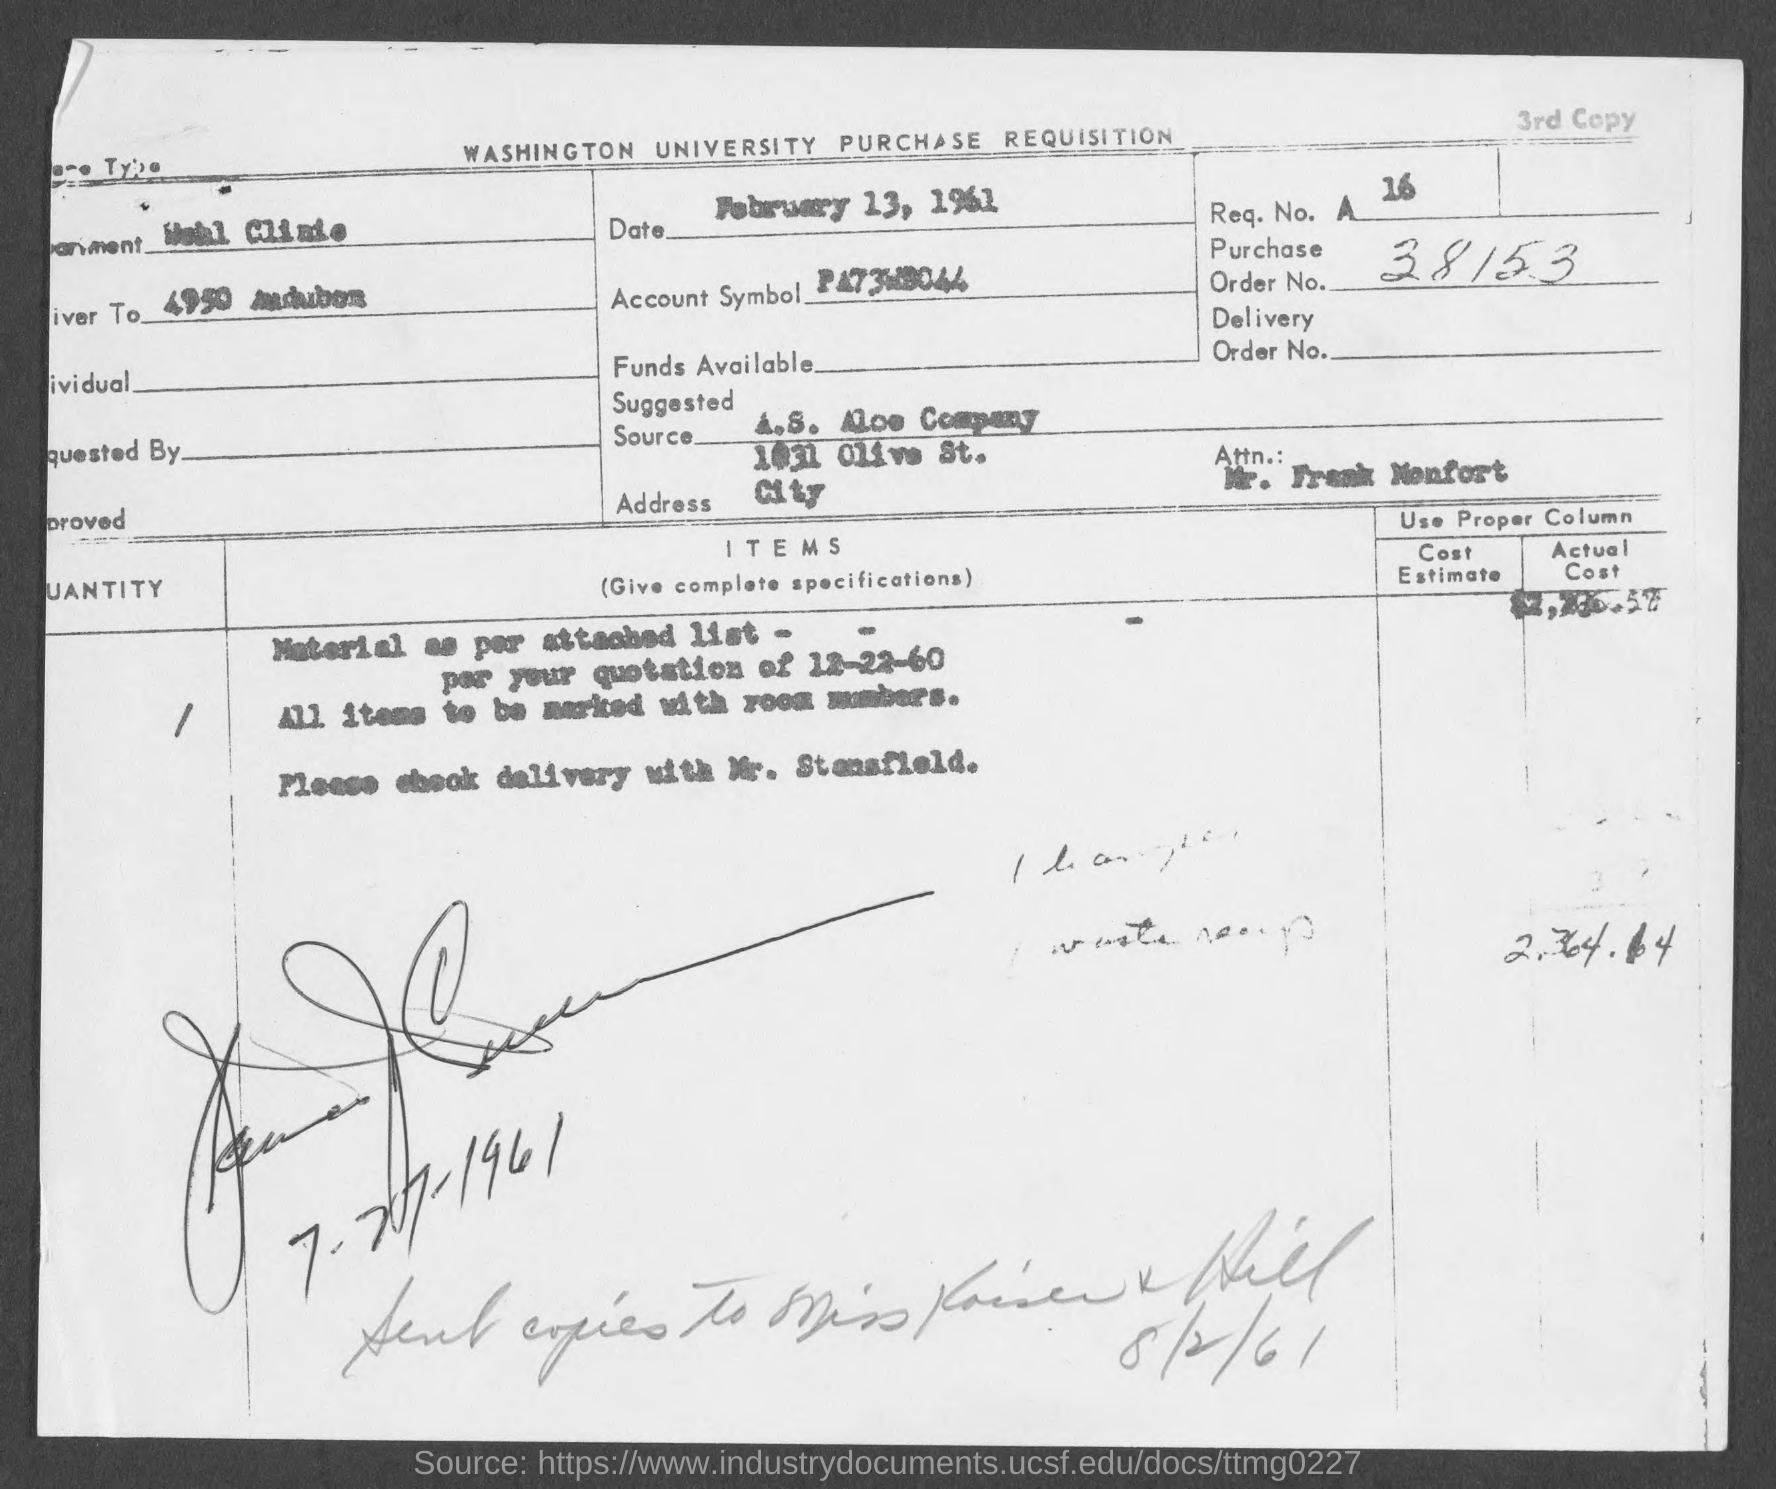What is the order no.?
Your answer should be compact. 38153. 